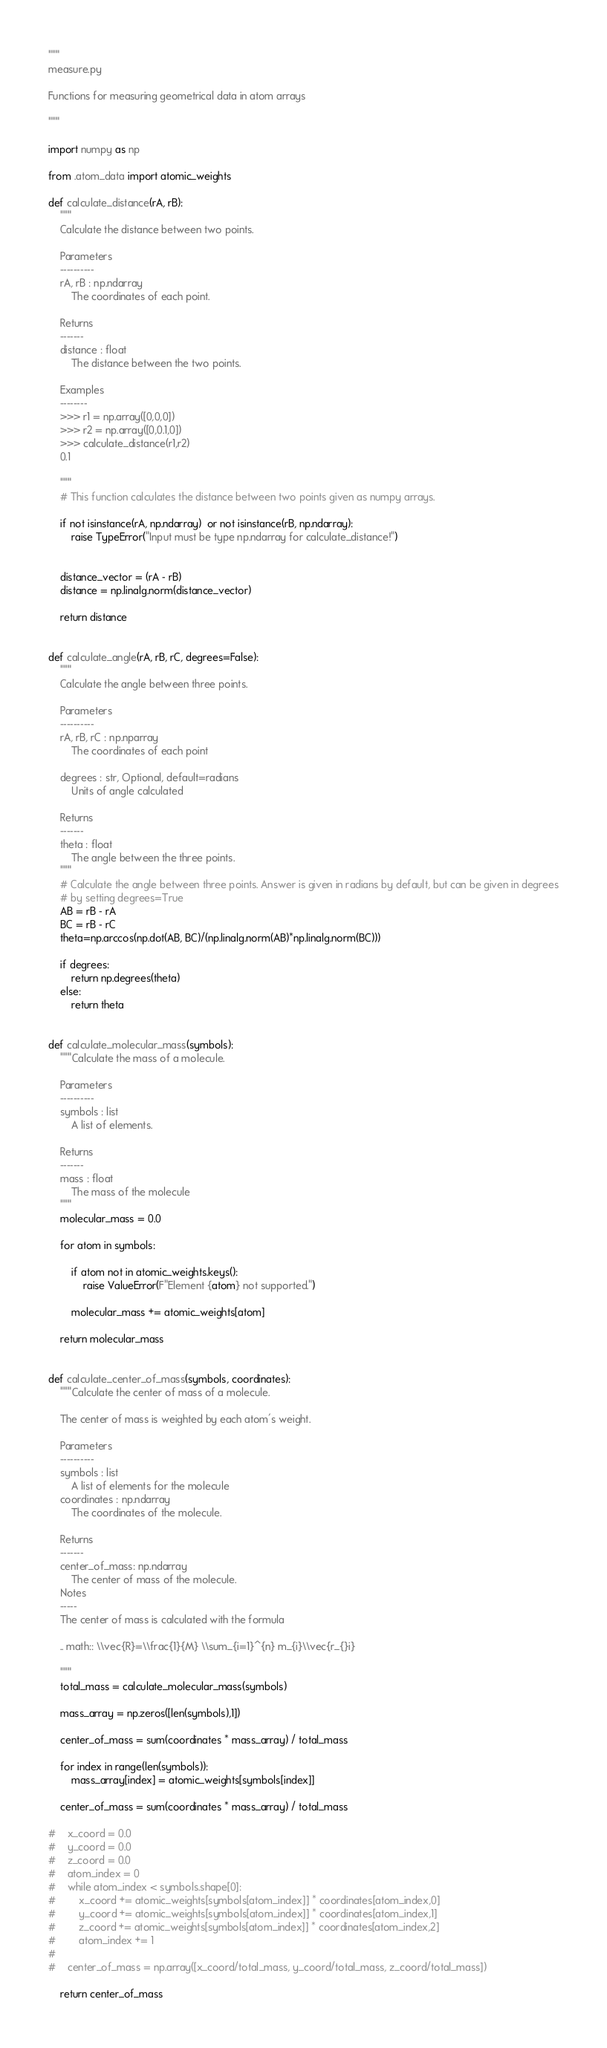<code> <loc_0><loc_0><loc_500><loc_500><_Python_>"""
measure.py

Functions for measuring geometrical data in atom arrays

"""

import numpy as np

from .atom_data import atomic_weights

def calculate_distance(rA, rB):
    """
    Calculate the distance between two points.

    Parameters
    ----------
    rA, rB : np.ndarray
        The coordinates of each point.

    Returns
    -------
    distance : float
        The distance between the two points.

    Examples
    --------
    >>> r1 = np.array([0,0,0])
    >>> r2 = np.array([0,0.1,0])
    >>> calculate_distance(r1,r2)
    0.1

    """
    # This function calculates the distance between two points given as numpy arrays.

    if not isinstance(rA, np.ndarray)  or not isinstance(rB, np.ndarray):
        raise TypeError("Input must be type np.ndarray for calculate_distance!")


    distance_vector = (rA - rB)
    distance = np.linalg.norm(distance_vector)

    return distance


def calculate_angle(rA, rB, rC, degrees=False):
    """
    Calculate the angle between three points.

    Parameters
    ----------
    rA, rB, rC : np.nparray
        The coordinates of each point

    degrees : str, Optional, default=radians
        Units of angle calculated

    Returns
    -------
    theta : float
        The angle between the three points.
    """
    # Calculate the angle between three points. Answer is given in radians by default, but can be given in degrees
    # by setting degrees=True
    AB = rB - rA
    BC = rB - rC
    theta=np.arccos(np.dot(AB, BC)/(np.linalg.norm(AB)*np.linalg.norm(BC)))

    if degrees:
        return np.degrees(theta)
    else:
        return theta


def calculate_molecular_mass(symbols):
    """Calculate the mass of a molecule.

    Parameters
    ----------
    symbols : list
        A list of elements.

    Returns
    -------
    mass : float
        The mass of the molecule
    """
    molecular_mass = 0.0

    for atom in symbols:

        if atom not in atomic_weights.keys():
            raise ValueError(F"Element {atom} not supported.")

        molecular_mass += atomic_weights[atom]
       
    return molecular_mass


def calculate_center_of_mass(symbols, coordinates):
    """Calculate the center of mass of a molecule.

    The center of mass is weighted by each atom's weight.

    Parameters
    ----------
    symbols : list
        A list of elements for the molecule
    coordinates : np.ndarray
        The coordinates of the molecule.
 
    Returns
    -------
    center_of_mass: np.ndarray
        The center of mass of the molecule.
    Notes
    -----
    The center of mass is calculated with the formula
 
    .. math:: \\vec{R}=\\frac{1}{M} \\sum_{i=1}^{n} m_{i}\\vec{r_{}i}
 
    """
    total_mass = calculate_molecular_mass(symbols)

    mass_array = np.zeros([len(symbols),1])
    
    center_of_mass = sum(coordinates * mass_array) / total_mass

    for index in range(len(symbols)):
        mass_array[index] = atomic_weights[symbols[index]]

    center_of_mass = sum(coordinates * mass_array) / total_mass

#    x_coord = 0.0
#    y_coord = 0.0
#    z_coord = 0.0
#    atom_index = 0
#    while atom_index < symbols.shape[0]:
#        x_coord += atomic_weights[symbols[atom_index]] * coordinates[atom_index,0]
#        y_coord += atomic_weights[symbols[atom_index]] * coordinates[atom_index,1]
#        z_coord += atomic_weights[symbols[atom_index]] * coordinates[atom_index,2]
#        atom_index += 1
#
#    center_of_mass = np.array([x_coord/total_mass, y_coord/total_mass, z_coord/total_mass])

    return center_of_mass
</code> 